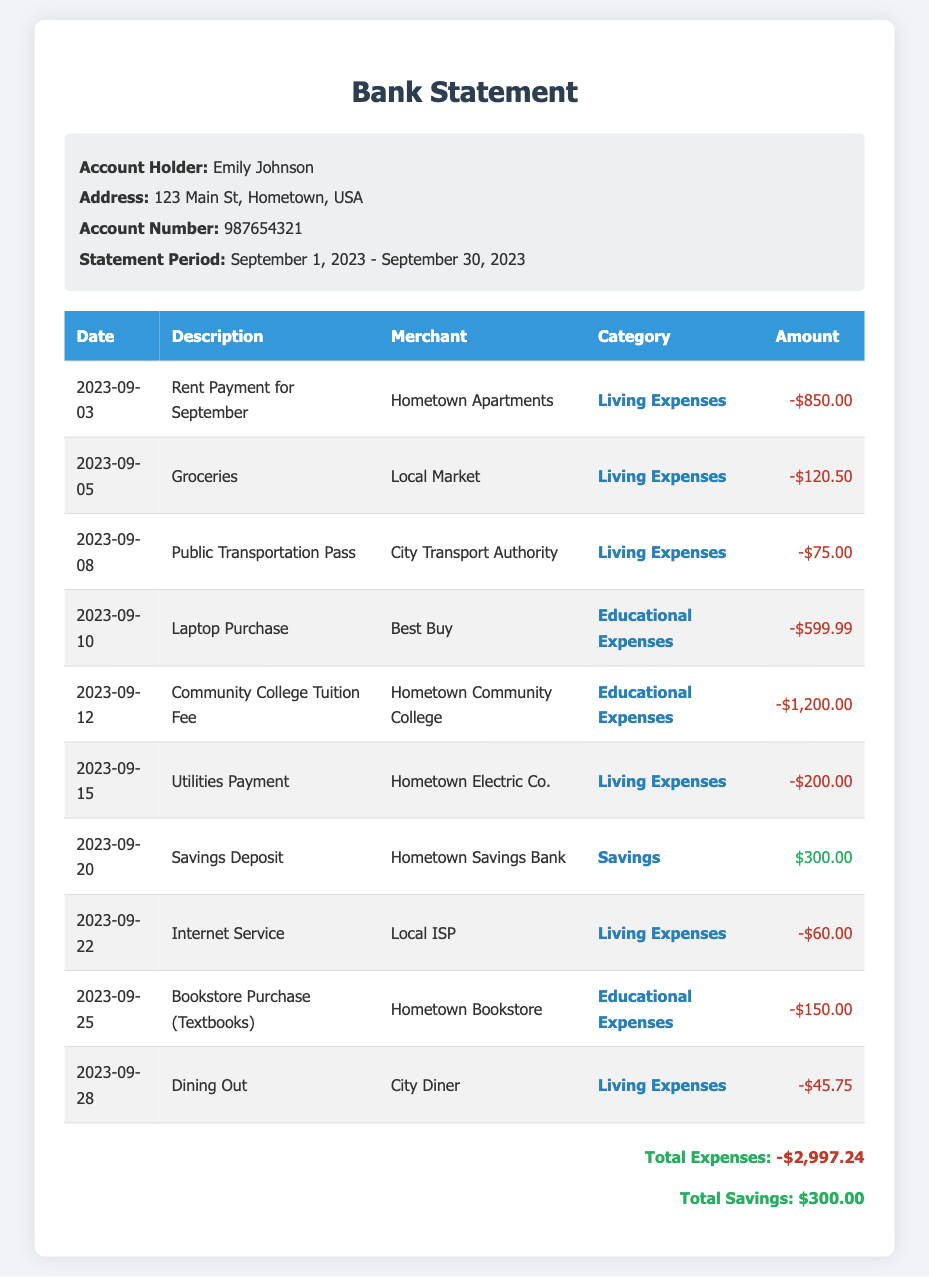What is the statement period? The statement period outlines the time frame for the transactions reported, which is from September 1, 2023 to September 30, 2023.
Answer: September 1, 2023 - September 30, 2023 Who is the account holder? The account holder's name is provided in the document, specifically in the account info section.
Answer: Emily Johnson How much was the rent payment? The rent payment amount is listed under the living expenses transactions, providing a clear monetary figure.
Answer: -$850.00 What is the total amount spent on living expenses? This total can be calculated by adding all the amounts categorized as living expenses in the table.
Answer: -$1,345.25 When was the savings deposit made? The date of the savings deposit is indicated within the transactions, showing when the deposit occurred for clarity.
Answer: 2023-09-20 What was purchased for educational purposes on September 10? The educational purchase made on that date is specifically listed, referring explicitly to the item's name.
Answer: Laptop Purchase How much was spent on textbooks? The transaction for textbooks gives the exact amount spent for educational resources to support learning.
Answer: -$150.00 What is the total savings amount? The savings amount is shown prominently in the summary section of the document, indicating total savings accrued.
Answer: $300.00 What service was paid for on September 22? The nature of the service transaction on that date is identifiable within the transaction description section of the document.
Answer: Internet Service 